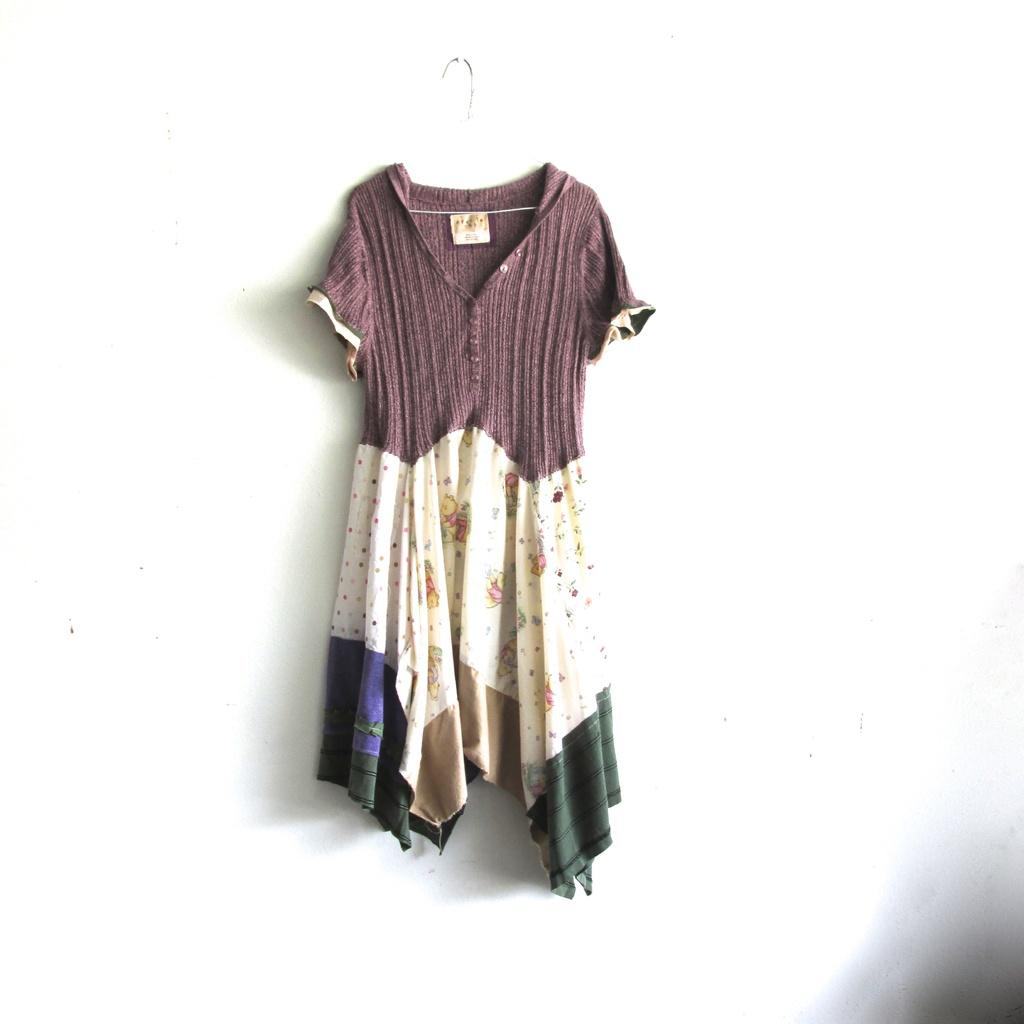What is the main subject in the center of the image? There is a cloth hanging in the center of the image. What type of sign is displayed on the cloth in the image? There is no sign present on the cloth in the image; it is just a cloth hanging in the center. What type of stove can be seen near the cloth in the image? There is no stove present in the image; it only features a cloth hanging in the center. 